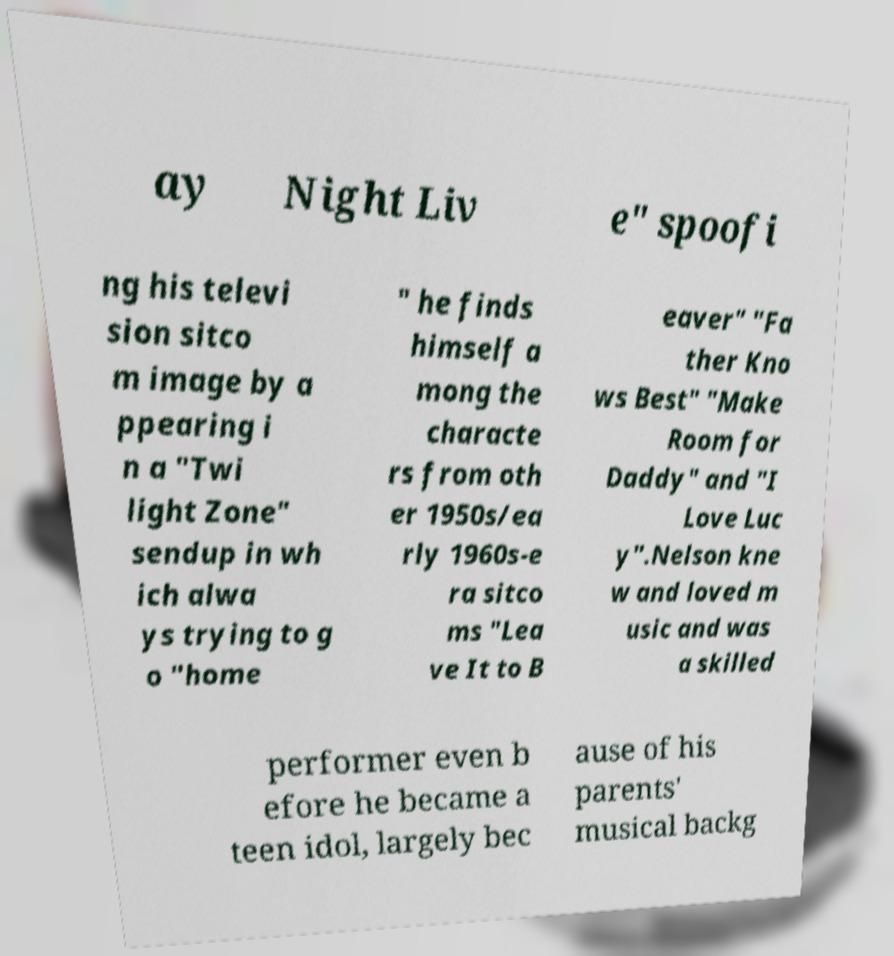I need the written content from this picture converted into text. Can you do that? ay Night Liv e" spoofi ng his televi sion sitco m image by a ppearing i n a "Twi light Zone" sendup in wh ich alwa ys trying to g o "home " he finds himself a mong the characte rs from oth er 1950s/ea rly 1960s-e ra sitco ms "Lea ve It to B eaver" "Fa ther Kno ws Best" "Make Room for Daddy" and "I Love Luc y".Nelson kne w and loved m usic and was a skilled performer even b efore he became a teen idol, largely bec ause of his parents' musical backg 